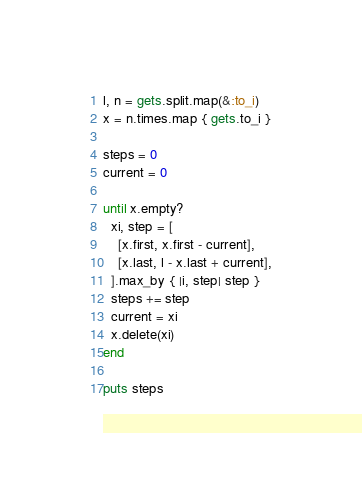<code> <loc_0><loc_0><loc_500><loc_500><_Ruby_>l, n = gets.split.map(&:to_i)
x = n.times.map { gets.to_i }
 
steps = 0
current = 0
 
until x.empty?
  xi, step = [
    [x.first, x.first - current],
    [x.last, l - x.last + current],
  ].max_by { |i, step| step }
  steps += step
  current = xi
  x.delete(xi)
end
 
puts steps</code> 